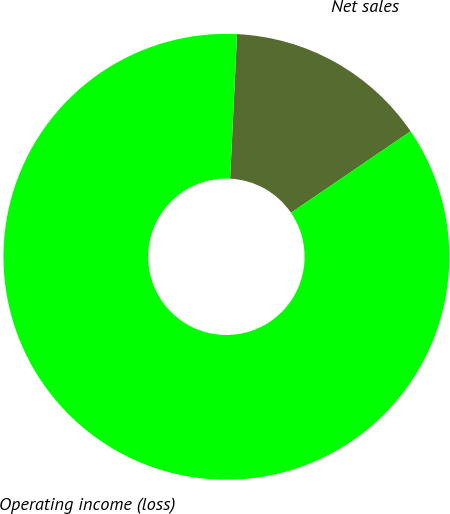Convert chart to OTSL. <chart><loc_0><loc_0><loc_500><loc_500><pie_chart><fcel>Net sales<fcel>Operating income (loss)<nl><fcel>14.72%<fcel>85.28%<nl></chart> 